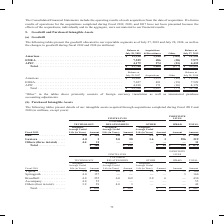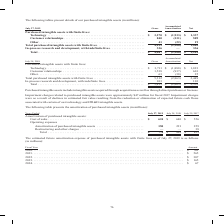According to Cisco Systems's financial document, What did purchased intangible assets include? intangible assets acquired through acquisitions as well as through direct purchases or licenses.. The document states: "Purchased intangible assets include intangible assets acquired through acquisitions as well as through direct purchases or licenses...." Also, How much were the impairment charges related to purchased intangible assets for fiscal 2017? According to the financial document, $47 million (in millions). The relevant text states: "to purchased intangible assets were approximately $47 million for fiscal 2017. Impairment charges were as a result of declines in estimated fair value resulting f..." Also, What was the amount of gross purchased technology? According to the financial document, 3,270 (in millions). The relevant text states: "tangible assets with finite lives: Technology . $ 3,270 $ (1,933) $ 1,337 Customer relationships . 840 (331) 509 Other . 41 (22) 19 Total purchased intangi..." Also, can you calculate: What was the difference in the net values between Technology and Customer relationships? Based on the calculation: 1,337-509, the result is 828 (in millions). This is based on the information: "th finite lives: Technology . $ 3,270 $ (1,933) $ 1,337 Customer relationships . 840 (331) 509 Other . 41 (22) 19 Total purchased intangible assets with fi 1,933) $ 1,337 Customer relationships . 840 ..." The key data points involved are: 1,337, 509. Also, How many Purchased intangible assets with finite lives had a gross amount that exceeded $1,000 million? Based on the analysis, there are 1 instances. The counting process: Technology. Also, can you calculate: What was the difference between the gross total and net total for all purchased intangible assets? Based on the calculation: 4,487-2,201, the result is 2286 (in millions). This is based on the information: "ment, with indefinite lives . 336 — 336 Total . $ 4,487 $ (2,286) $ 2,201 ite lives . 336 — 336 Total . $ 4,487 $ (2,286) $ 2,201..." The key data points involved are: 2,201, 4,487. 